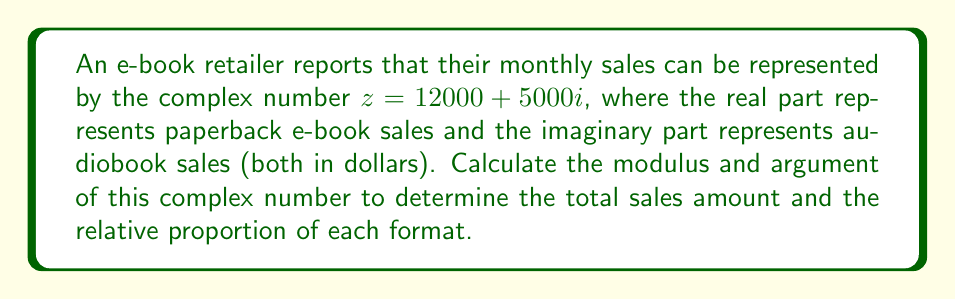Can you solve this math problem? To solve this problem, we need to calculate the modulus and argument of the given complex number $z = 12000 + 5000i$.

1. Calculating the modulus:
   The modulus of a complex number $z = a + bi$ is given by the formula:
   $$ |z| = \sqrt{a^2 + b^2} $$
   
   In this case:
   $$ |z| = \sqrt{12000^2 + 5000^2} $$
   $$ |z| = \sqrt{144,000,000 + 25,000,000} $$
   $$ |z| = \sqrt{169,000,000} $$
   $$ |z| = 13,000 $$

2. Calculating the argument:
   The argument of a complex number is the angle it makes with the positive real axis. It can be calculated using the arctangent function:
   $$ \arg(z) = \tan^{-1}\left(\frac{b}{a}\right) $$
   
   In this case:
   $$ \arg(z) = \tan^{-1}\left(\frac{5000}{12000}\right) $$
   $$ \arg(z) = \tan^{-1}\left(\frac{5}{12}\right) $$
   $$ \arg(z) \approx 0.3947 \text{ radians} $$

   To convert to degrees:
   $$ 0.3947 \text{ radians} \times \frac{180°}{\pi} \approx 22.62° $$

The modulus represents the total sales amount, while the argument represents the relative proportion of audiobook sales to paperback e-book sales.
Answer: Modulus: $|z| = 13,000$
Argument: $\arg(z) \approx 0.3947 \text{ radians}$ or $22.62°$ 